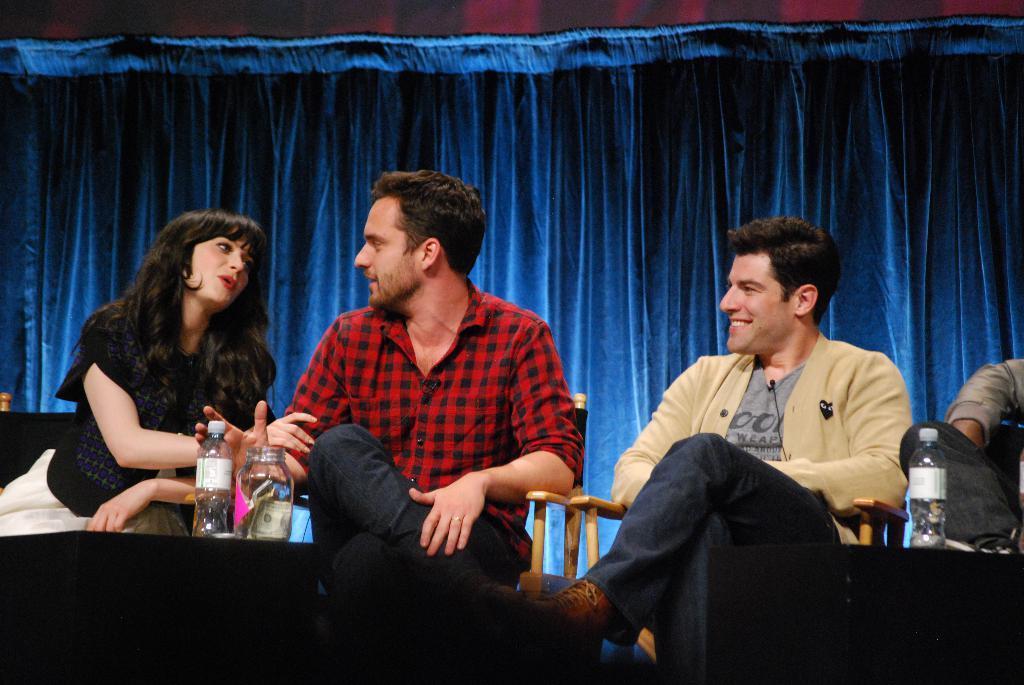Could you give a brief overview of what you see in this image? In this image I can see few persons are sitting on wooden chairs. I can see few black colored objects in front of them and on them I can see few bottles. I can see the blue colored curtain in the background. 